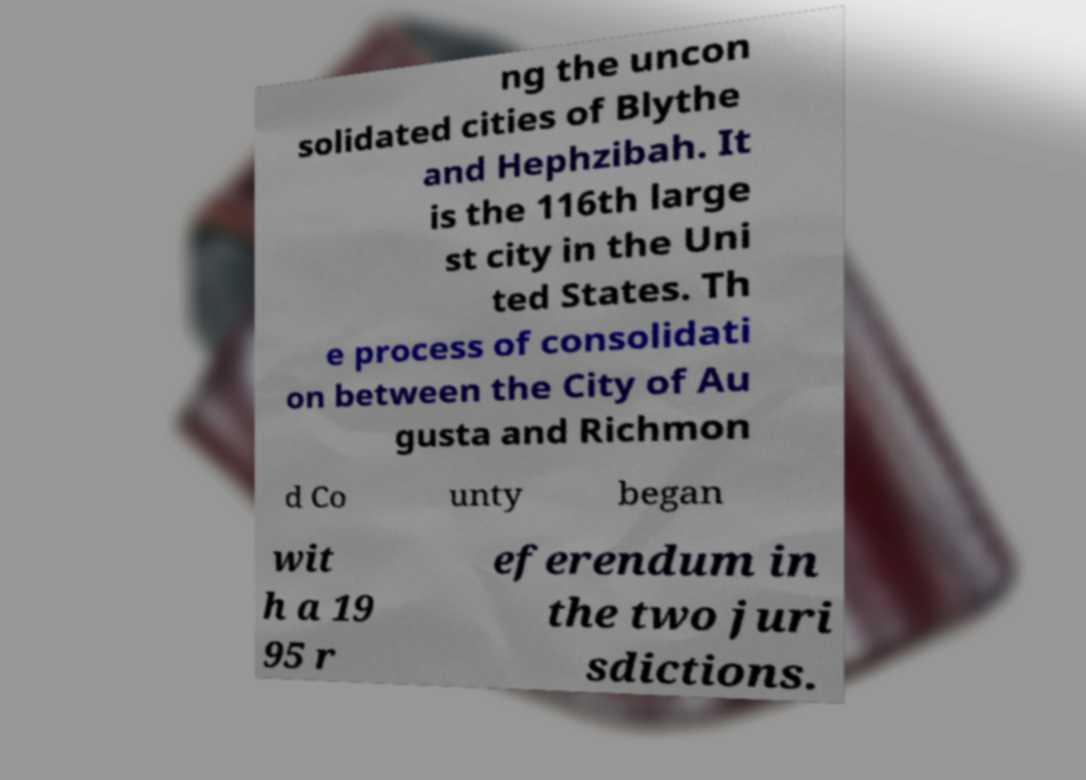Can you read and provide the text displayed in the image?This photo seems to have some interesting text. Can you extract and type it out for me? ng the uncon solidated cities of Blythe and Hephzibah. It is the 116th large st city in the Uni ted States. Th e process of consolidati on between the City of Au gusta and Richmon d Co unty began wit h a 19 95 r eferendum in the two juri sdictions. 